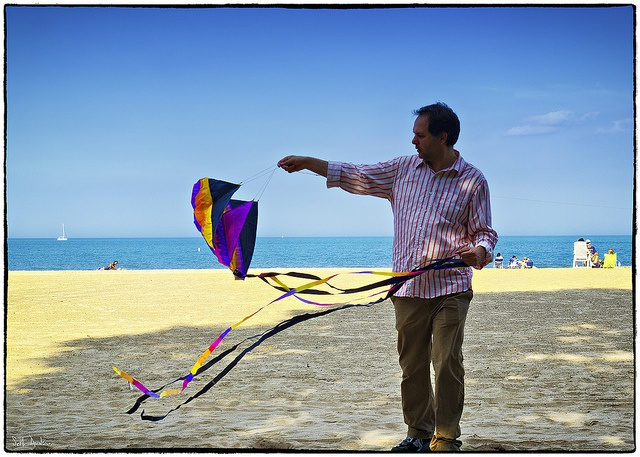Describe the objects in this image and their specific colors. I can see people in white, black, maroon, and gray tones, kite in white, khaki, black, darkgray, and navy tones, chair in white, ivory, darkgray, beige, and lightblue tones, chair in white, yellow, khaki, and olive tones, and people in white, lightblue, tan, khaki, and darkblue tones in this image. 